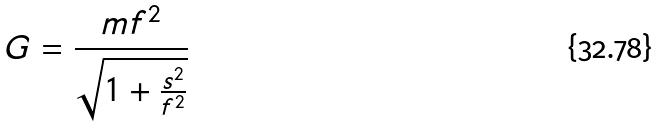<formula> <loc_0><loc_0><loc_500><loc_500>G = \frac { m f ^ { 2 } } { \sqrt { 1 + \frac { s ^ { 2 } } { f ^ { 2 } } } }</formula> 